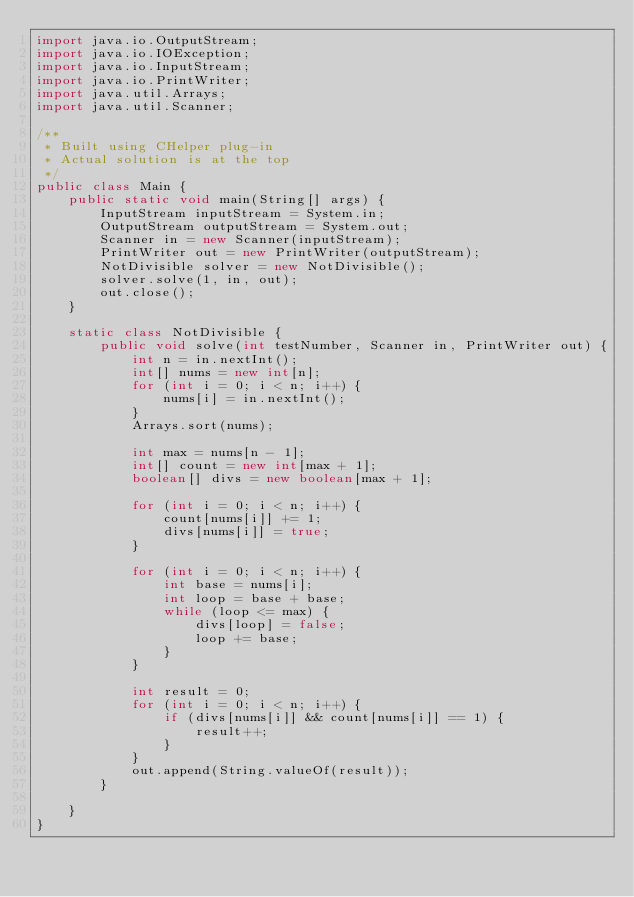Convert code to text. <code><loc_0><loc_0><loc_500><loc_500><_Java_>import java.io.OutputStream;
import java.io.IOException;
import java.io.InputStream;
import java.io.PrintWriter;
import java.util.Arrays;
import java.util.Scanner;

/**
 * Built using CHelper plug-in
 * Actual solution is at the top
 */
public class Main {
    public static void main(String[] args) {
        InputStream inputStream = System.in;
        OutputStream outputStream = System.out;
        Scanner in = new Scanner(inputStream);
        PrintWriter out = new PrintWriter(outputStream);
        NotDivisible solver = new NotDivisible();
        solver.solve(1, in, out);
        out.close();
    }

    static class NotDivisible {
        public void solve(int testNumber, Scanner in, PrintWriter out) {
            int n = in.nextInt();
            int[] nums = new int[n];
            for (int i = 0; i < n; i++) {
                nums[i] = in.nextInt();
            }
            Arrays.sort(nums);

            int max = nums[n - 1];
            int[] count = new int[max + 1];
            boolean[] divs = new boolean[max + 1];

            for (int i = 0; i < n; i++) {
                count[nums[i]] += 1;
                divs[nums[i]] = true;
            }

            for (int i = 0; i < n; i++) {
                int base = nums[i];
                int loop = base + base;
                while (loop <= max) {
                    divs[loop] = false;
                    loop += base;
                }
            }

            int result = 0;
            for (int i = 0; i < n; i++) {
                if (divs[nums[i]] && count[nums[i]] == 1) {
                    result++;
                }
            }
            out.append(String.valueOf(result));
        }

    }
}

</code> 